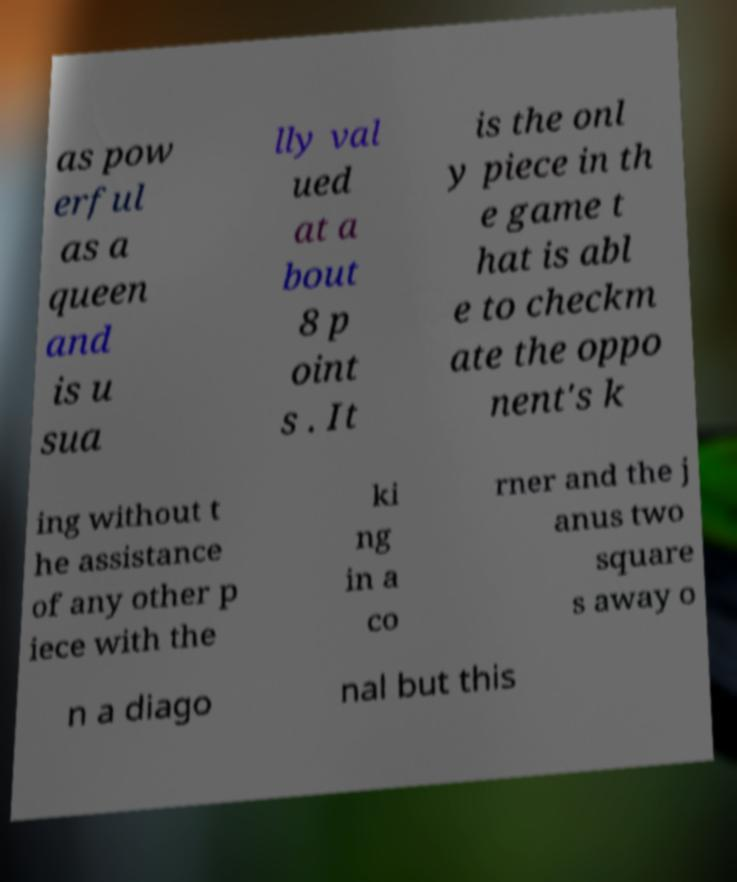Please identify and transcribe the text found in this image. as pow erful as a queen and is u sua lly val ued at a bout 8 p oint s . It is the onl y piece in th e game t hat is abl e to checkm ate the oppo nent's k ing without t he assistance of any other p iece with the ki ng in a co rner and the j anus two square s away o n a diago nal but this 